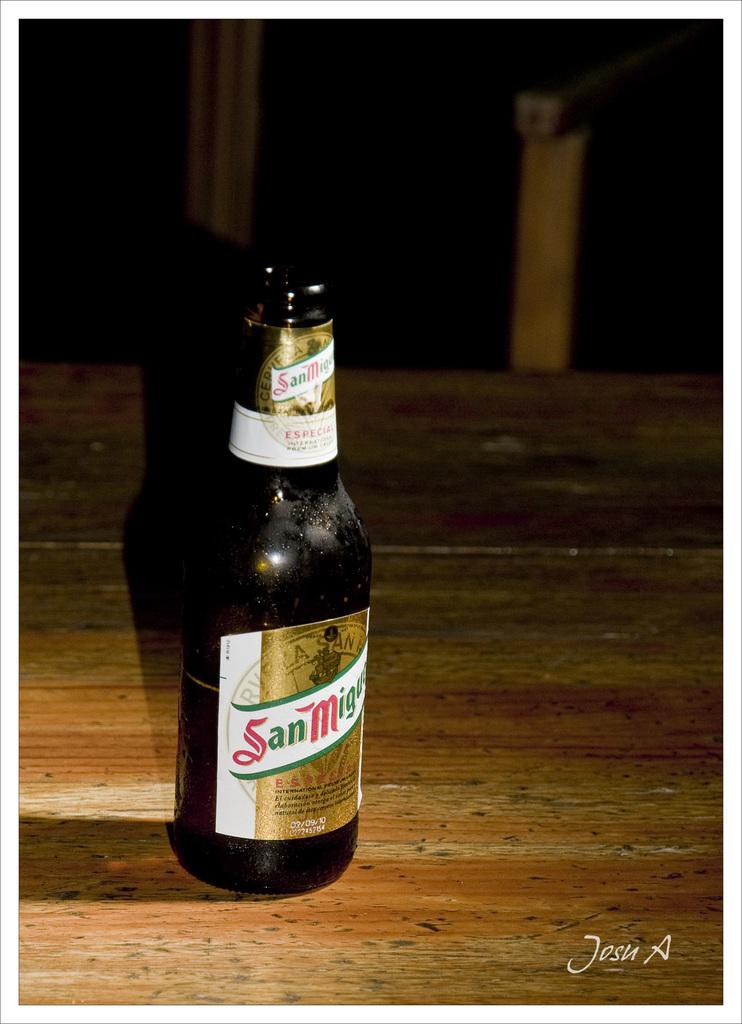What are the letters in red?
Provide a succinct answer. S and m. 